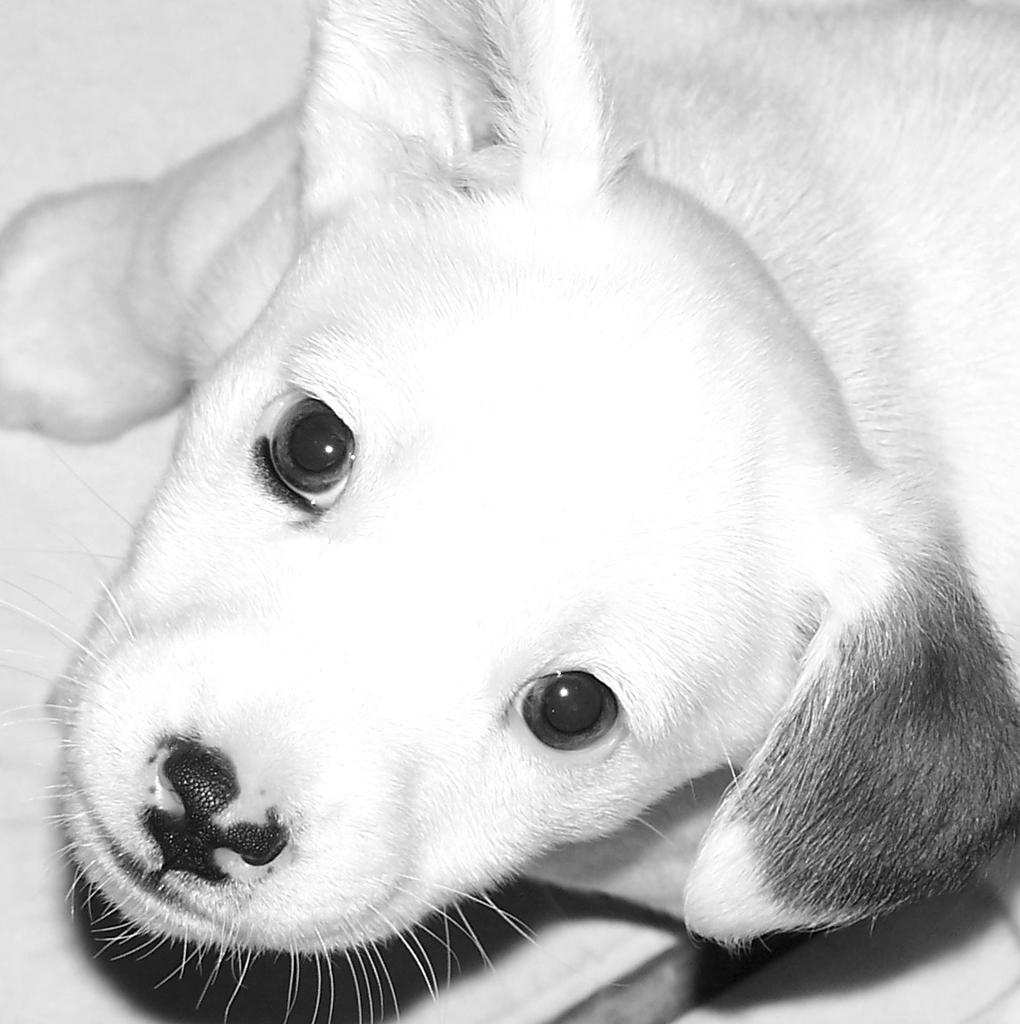What type of animal is in the image? There is a white dog in the image. What color is the dog? The dog is white. What can be seen in the background of the image? The background of the image is white. Where is the lunchroom located in the image? There is no lunchroom present in the image; it features a white dog against a white background. How many dogs are depicted in the image? There is only one dog in the image, which is a white dog. 